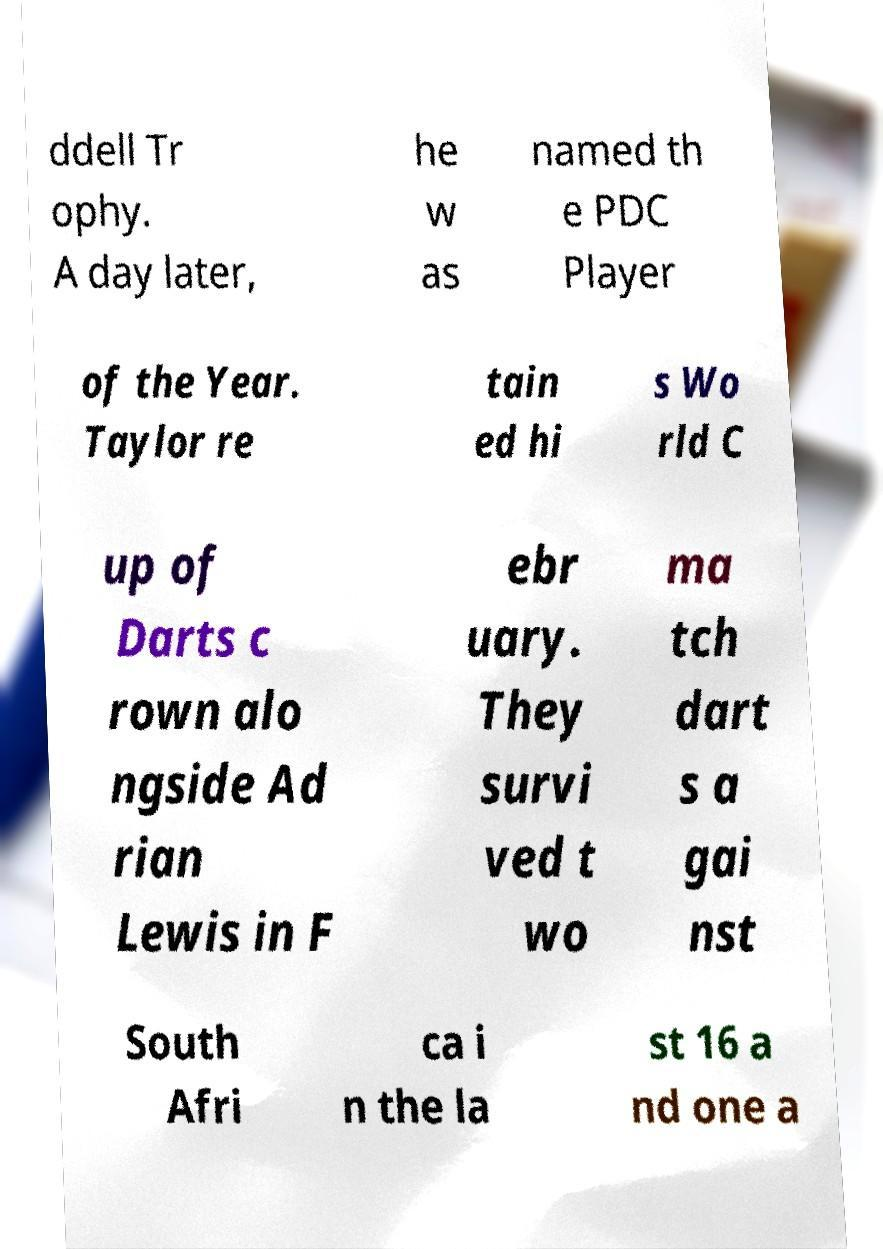Please identify and transcribe the text found in this image. ddell Tr ophy. A day later, he w as named th e PDC Player of the Year. Taylor re tain ed hi s Wo rld C up of Darts c rown alo ngside Ad rian Lewis in F ebr uary. They survi ved t wo ma tch dart s a gai nst South Afri ca i n the la st 16 a nd one a 